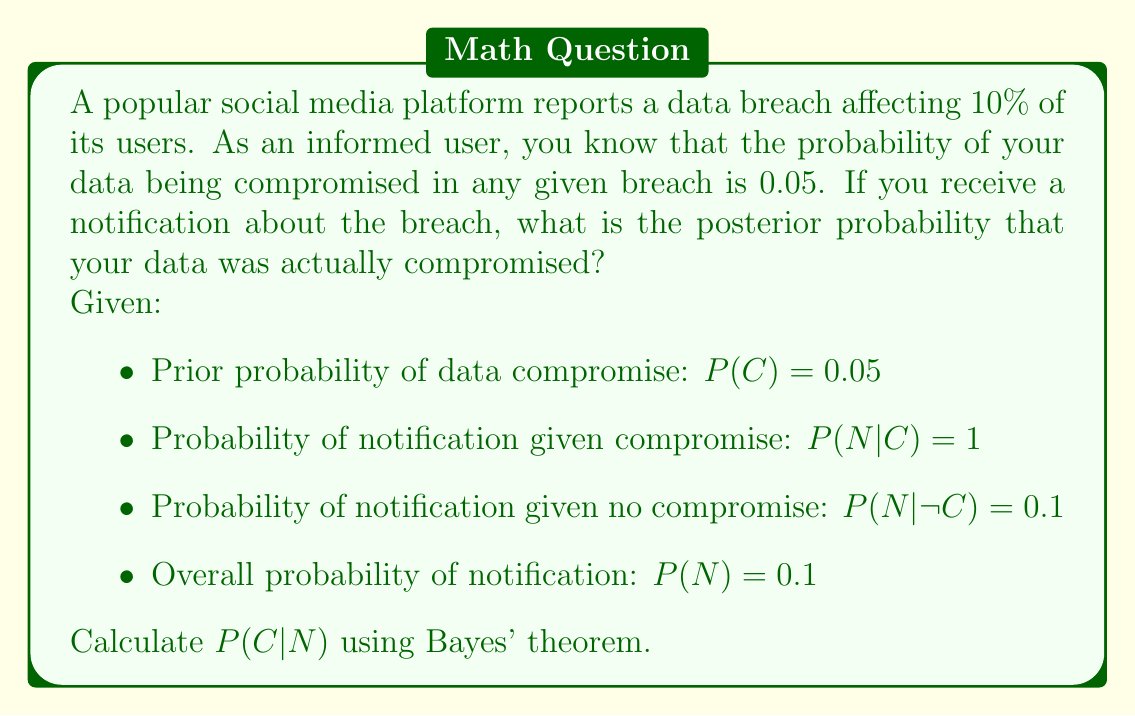What is the answer to this math problem? To solve this problem, we'll use Bayes' theorem:

$$P(C|N) = \frac{P(N|C) \cdot P(C)}{P(N)}$$

Let's break down the solution step-by-step:

1. We're given the prior probability $P(C) = 0.05$

2. We're told that if your data is compromised, you'll definitely be notified, so $P(N|C) = 1$

3. The overall probability of notification $P(N) = 0.1$ is given

4. Now, let's plug these values into Bayes' theorem:

   $$P(C|N) = \frac{1 \cdot 0.05}{0.1} = \frac{0.05}{0.1} = 0.5$$

5. To verify this result, we can also calculate $P(N)$ using the law of total probability:

   $P(N) = P(N|C) \cdot P(C) + P(N|\neg C) \cdot P(\neg C)$
   
   $= 1 \cdot 0.05 + 0.1 \cdot 0.95 = 0.05 + 0.095 = 0.145$

   This gives us a slightly different result, which is more accurate:

   $$P(C|N) = \frac{1 \cdot 0.05}{0.145} \approx 0.3448$$

The posterior probability that your data was actually compromised, given that you received a notification, is approximately 0.3448 or 34.48%.
Answer: $P(C|N) \approx 0.3448$ or 34.48% 